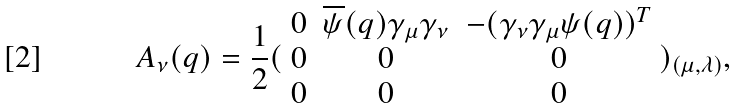<formula> <loc_0><loc_0><loc_500><loc_500>A _ { \nu } ( q ) = \frac { 1 } { 2 } ( \begin{array} { c c c } 0 & \overline { \psi } ( q ) \gamma _ { \mu } \gamma _ { \nu } & - ( \gamma _ { \nu } \gamma _ { \mu } \psi ( q ) ) ^ { T } \\ 0 & 0 & 0 \\ 0 & 0 & 0 \end{array} ) _ { ( \mu , \lambda ) } ,</formula> 